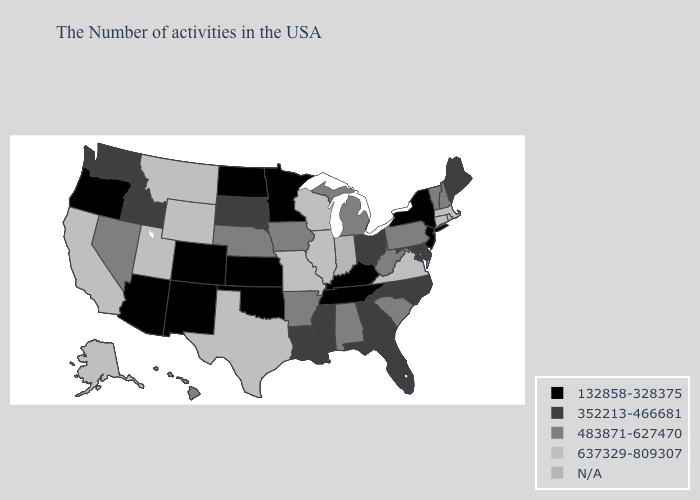What is the value of Massachusetts?
Write a very short answer. 637329-809307. What is the highest value in states that border Texas?
Quick response, please. 483871-627470. Name the states that have a value in the range 483871-627470?
Concise answer only. New Hampshire, Vermont, Pennsylvania, South Carolina, West Virginia, Michigan, Alabama, Arkansas, Iowa, Nebraska, Nevada, Hawaii. What is the value of South Dakota?
Keep it brief. 352213-466681. Does North Carolina have the highest value in the South?
Quick response, please. No. What is the highest value in the USA?
Short answer required. 637329-809307. Does Pennsylvania have the lowest value in the USA?
Be succinct. No. Among the states that border New Jersey , does Pennsylvania have the highest value?
Short answer required. Yes. Name the states that have a value in the range 483871-627470?
Short answer required. New Hampshire, Vermont, Pennsylvania, South Carolina, West Virginia, Michigan, Alabama, Arkansas, Iowa, Nebraska, Nevada, Hawaii. What is the value of Arizona?
Write a very short answer. 132858-328375. Which states have the lowest value in the Northeast?
Keep it brief. New York, New Jersey. Does Ohio have the highest value in the MidWest?
Quick response, please. No. Name the states that have a value in the range 483871-627470?
Be succinct. New Hampshire, Vermont, Pennsylvania, South Carolina, West Virginia, Michigan, Alabama, Arkansas, Iowa, Nebraska, Nevada, Hawaii. Does the first symbol in the legend represent the smallest category?
Be succinct. Yes. What is the value of Utah?
Keep it brief. 637329-809307. 